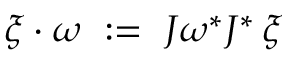Convert formula to latex. <formula><loc_0><loc_0><loc_500><loc_500>\xi \cdot \omega \ \colon = \ J \omega ^ { * } J ^ { * } \, \xi</formula> 